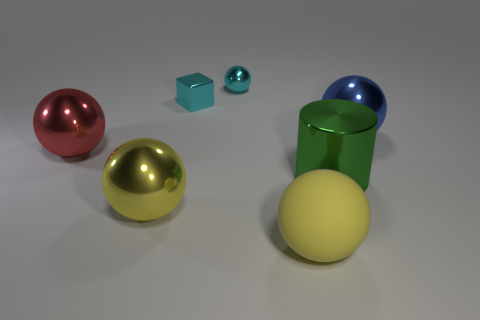Are there more big yellow balls left of the big matte object than tiny cylinders?
Offer a terse response. Yes. The cyan shiny thing that is the same shape as the big yellow metallic object is what size?
Ensure brevity in your answer.  Small. What shape is the blue metallic thing?
Provide a succinct answer. Sphere. The metal object that is the same size as the metal cube is what shape?
Ensure brevity in your answer.  Sphere. Is there any other thing that is the same color as the cube?
Give a very brief answer. Yes. What is the size of the cyan ball that is the same material as the green thing?
Provide a short and direct response. Small. Does the big blue shiny object have the same shape as the metallic thing that is in front of the large green metallic thing?
Your answer should be compact. Yes. What is the size of the metal cube?
Your answer should be very brief. Small. Is the number of red spheres in front of the shiny cylinder less than the number of red spheres?
Your answer should be compact. Yes. How many other spheres have the same size as the yellow metal ball?
Ensure brevity in your answer.  3. 